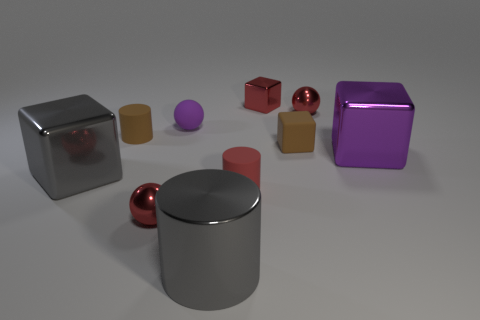Subtract all tiny matte cylinders. How many cylinders are left? 1 Subtract all purple spheres. How many spheres are left? 2 Subtract all blocks. How many objects are left? 6 Subtract 0 green cylinders. How many objects are left? 10 Subtract 2 spheres. How many spheres are left? 1 Subtract all yellow cubes. Subtract all yellow cylinders. How many cubes are left? 4 Subtract all purple cylinders. How many green spheres are left? 0 Subtract all big blue shiny blocks. Subtract all tiny purple rubber balls. How many objects are left? 9 Add 6 tiny purple things. How many tiny purple things are left? 7 Add 5 gray things. How many gray things exist? 7 